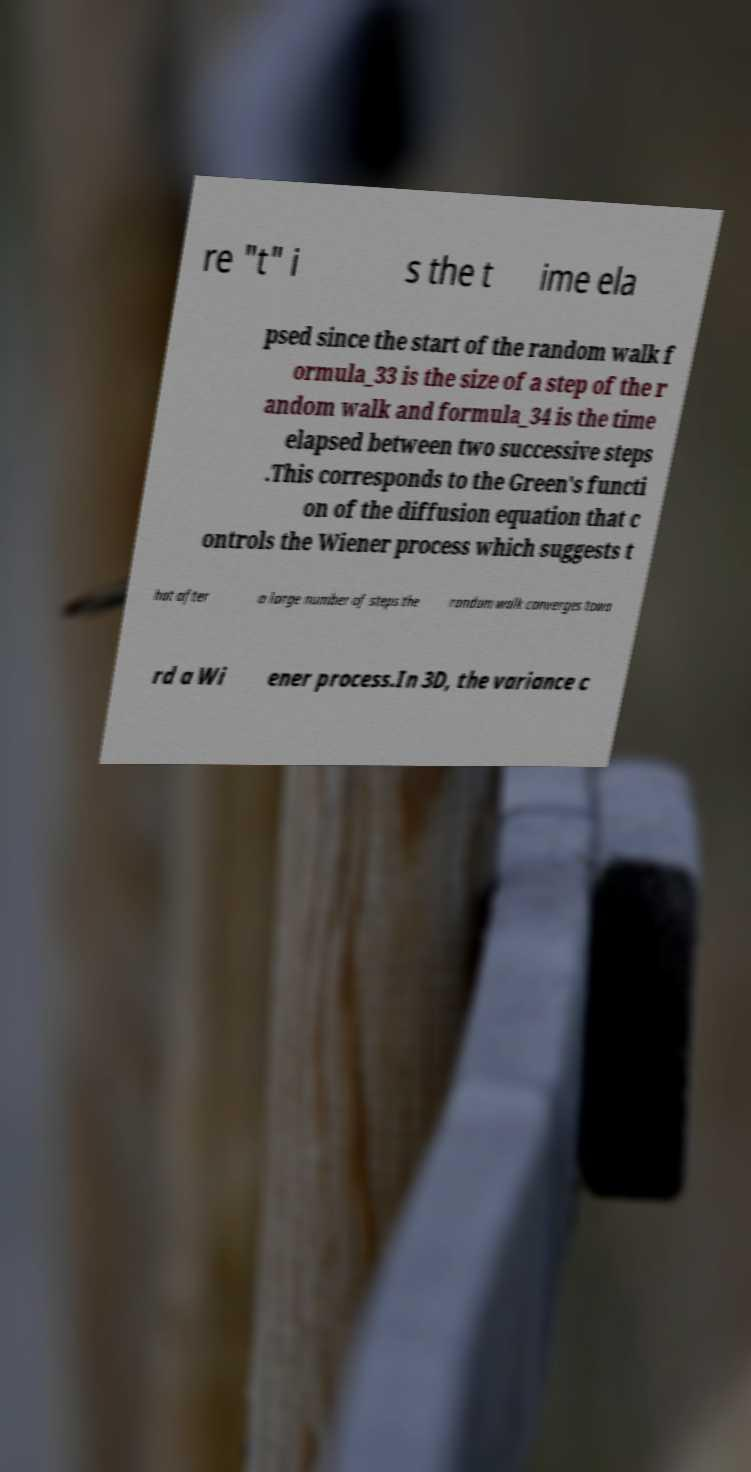For documentation purposes, I need the text within this image transcribed. Could you provide that? re "t" i s the t ime ela psed since the start of the random walk f ormula_33 is the size of a step of the r andom walk and formula_34 is the time elapsed between two successive steps .This corresponds to the Green's functi on of the diffusion equation that c ontrols the Wiener process which suggests t hat after a large number of steps the random walk converges towa rd a Wi ener process.In 3D, the variance c 